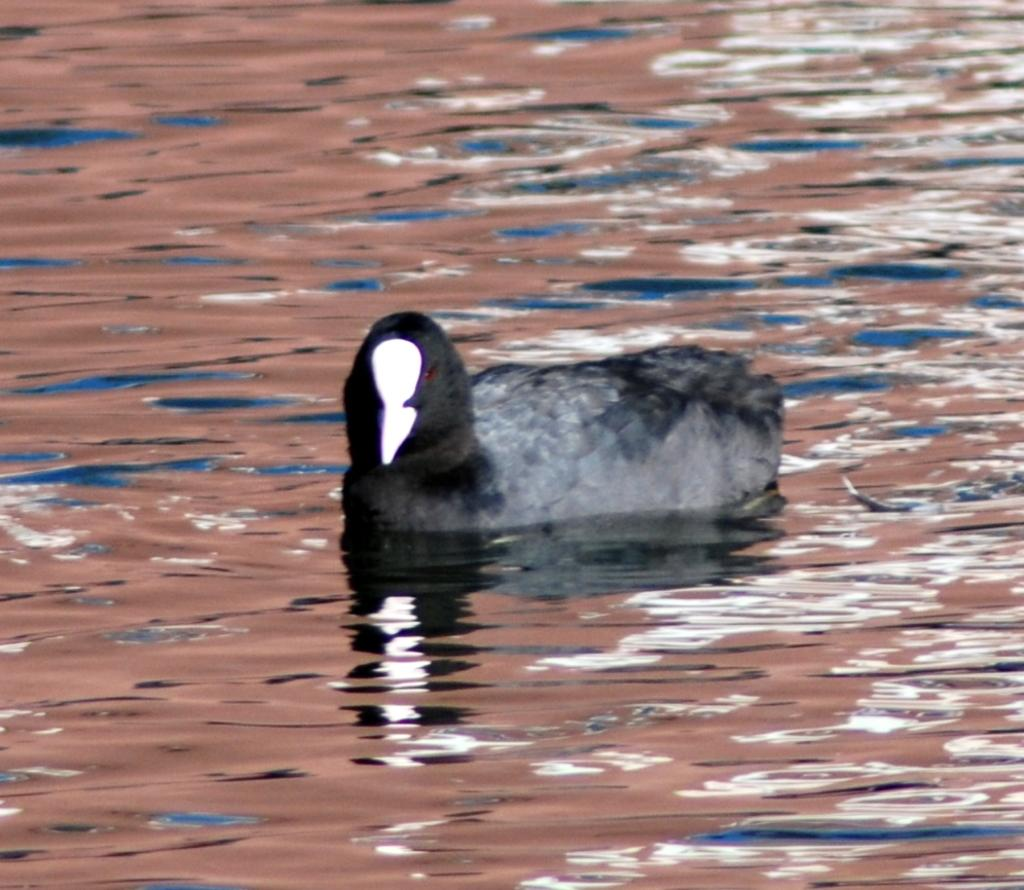What type of animal can be seen in the image? There is a bird in the image. Where is the bird located in the image? The bird is on the surface of the water. Reasoning: Let' Let's think step by step in order to produce the conversation. We start by identifying the main subject in the image, which is the bird. Then, we describe the bird's location, which is on the surface of the water. We avoid asking questions that cannot be answered definitively with the information given and ensure that the language is simple and clear. Absurd Question/Answer: What type of house is visible in the image? There is no house present in the image; it features a bird on the surface of the water. How is the bird measuring the depth of the water in the image? The bird is not measuring the depth of the water in the image; it is simply on the surface of the water. 